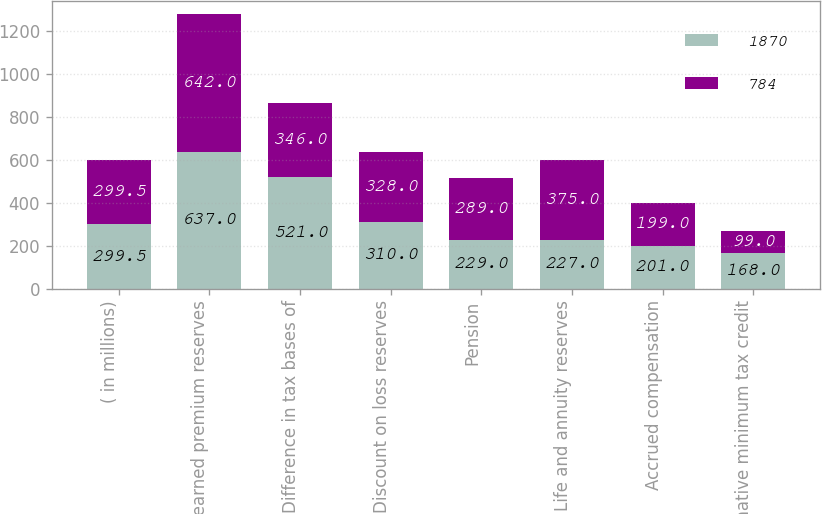<chart> <loc_0><loc_0><loc_500><loc_500><stacked_bar_chart><ecel><fcel>( in millions)<fcel>Unearned premium reserves<fcel>Difference in tax bases of<fcel>Discount on loss reserves<fcel>Pension<fcel>Life and annuity reserves<fcel>Accrued compensation<fcel>Alternative minimum tax credit<nl><fcel>1870<fcel>299.5<fcel>637<fcel>521<fcel>310<fcel>229<fcel>227<fcel>201<fcel>168<nl><fcel>784<fcel>299.5<fcel>642<fcel>346<fcel>328<fcel>289<fcel>375<fcel>199<fcel>99<nl></chart> 